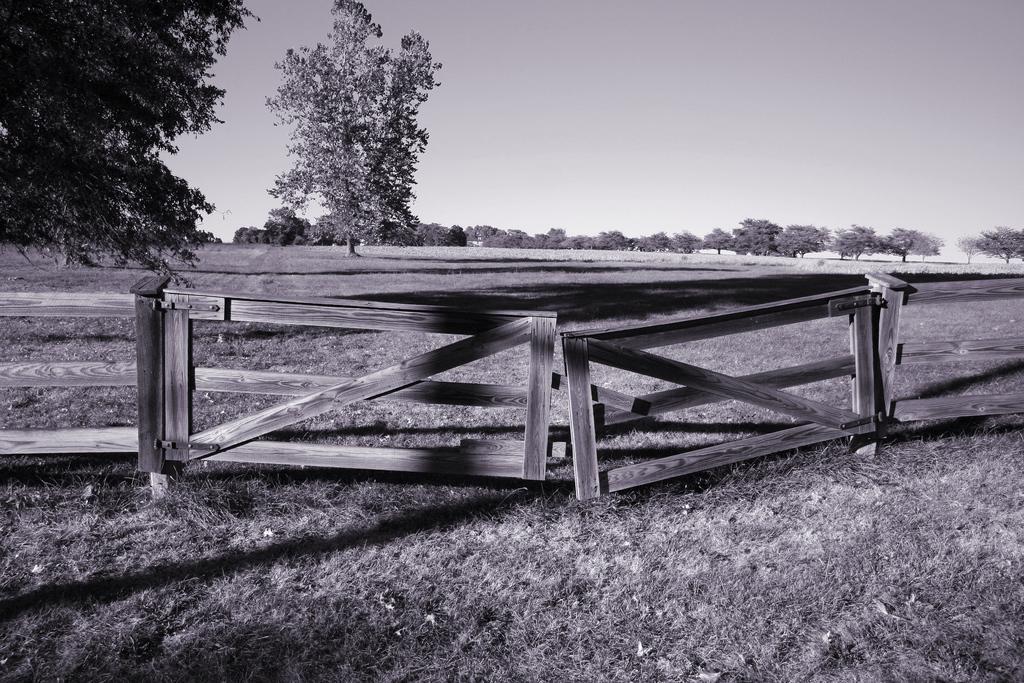Could you give a brief overview of what you see in this image? This picture is clicked outside. In the center we can see the wooden fence and the grass. In the background we can see the sky and the trees. 